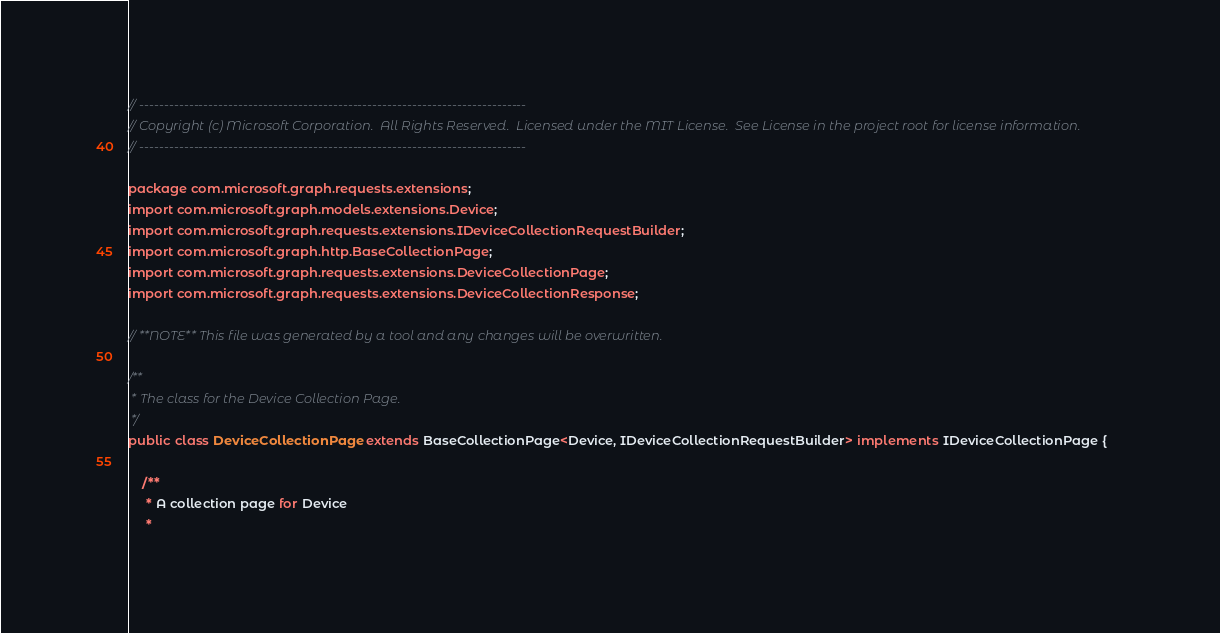Convert code to text. <code><loc_0><loc_0><loc_500><loc_500><_Java_>// ------------------------------------------------------------------------------
// Copyright (c) Microsoft Corporation.  All Rights Reserved.  Licensed under the MIT License.  See License in the project root for license information.
// ------------------------------------------------------------------------------

package com.microsoft.graph.requests.extensions;
import com.microsoft.graph.models.extensions.Device;
import com.microsoft.graph.requests.extensions.IDeviceCollectionRequestBuilder;
import com.microsoft.graph.http.BaseCollectionPage;
import com.microsoft.graph.requests.extensions.DeviceCollectionPage;
import com.microsoft.graph.requests.extensions.DeviceCollectionResponse;

// **NOTE** This file was generated by a tool and any changes will be overwritten.

/**
 * The class for the Device Collection Page.
 */
public class DeviceCollectionPage extends BaseCollectionPage<Device, IDeviceCollectionRequestBuilder> implements IDeviceCollectionPage {

    /**
     * A collection page for Device
     *</code> 